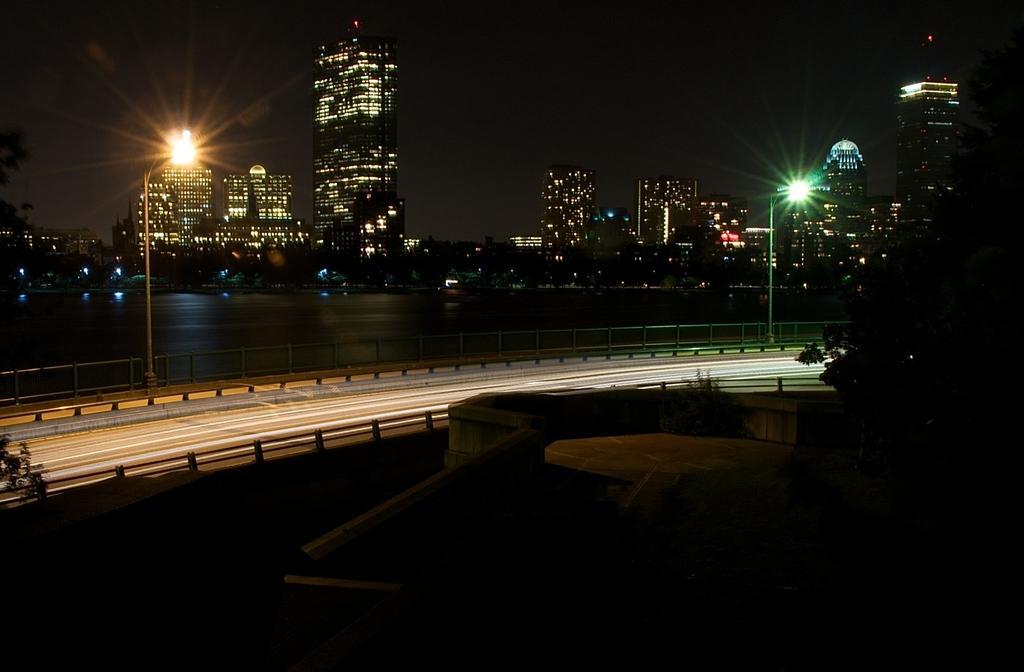Please provide a concise description of this image. In this picture there is a road and there are two street lights beside it and there is a tree in the right corner and there are few buildings and water in the background. 